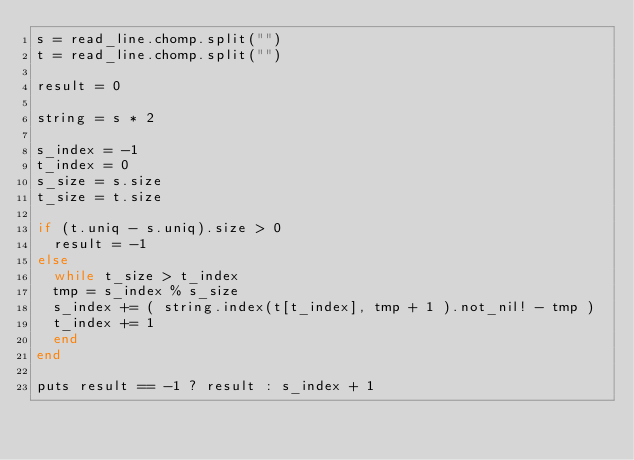<code> <loc_0><loc_0><loc_500><loc_500><_Crystal_>s = read_line.chomp.split("")
t = read_line.chomp.split("")

result = 0

string = s * 2

s_index = -1
t_index = 0
s_size = s.size
t_size = t.size

if (t.uniq - s.uniq).size > 0
  result = -1
else
  while t_size > t_index
	tmp = s_index % s_size
	s_index += ( string.index(t[t_index], tmp + 1 ).not_nil! - tmp )
	t_index += 1
  end
end

puts result == -1 ? result : s_index + 1
</code> 